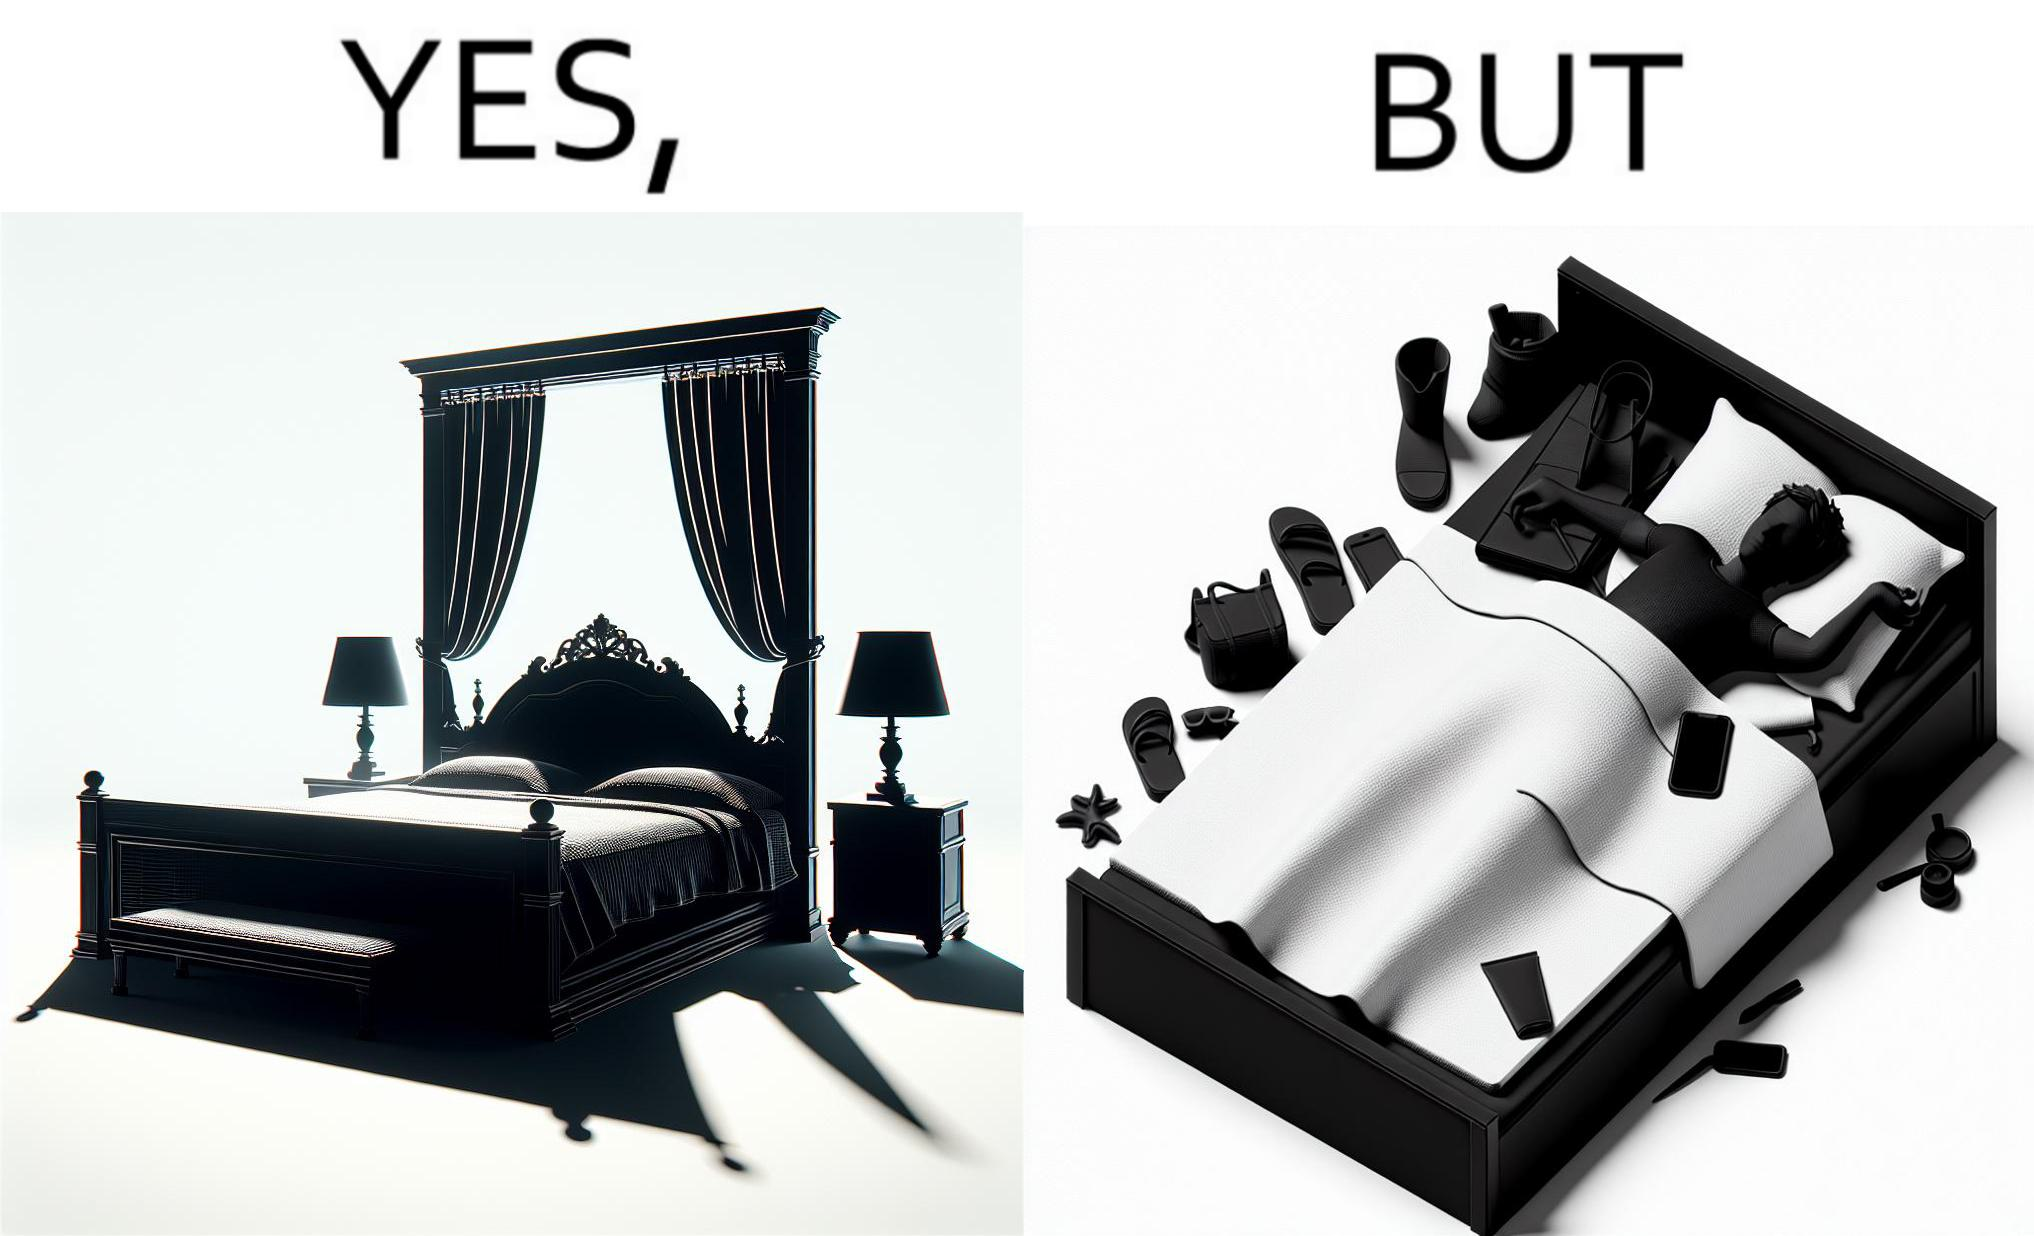Does this image contain satire or humor? Yes, this image is satirical. 